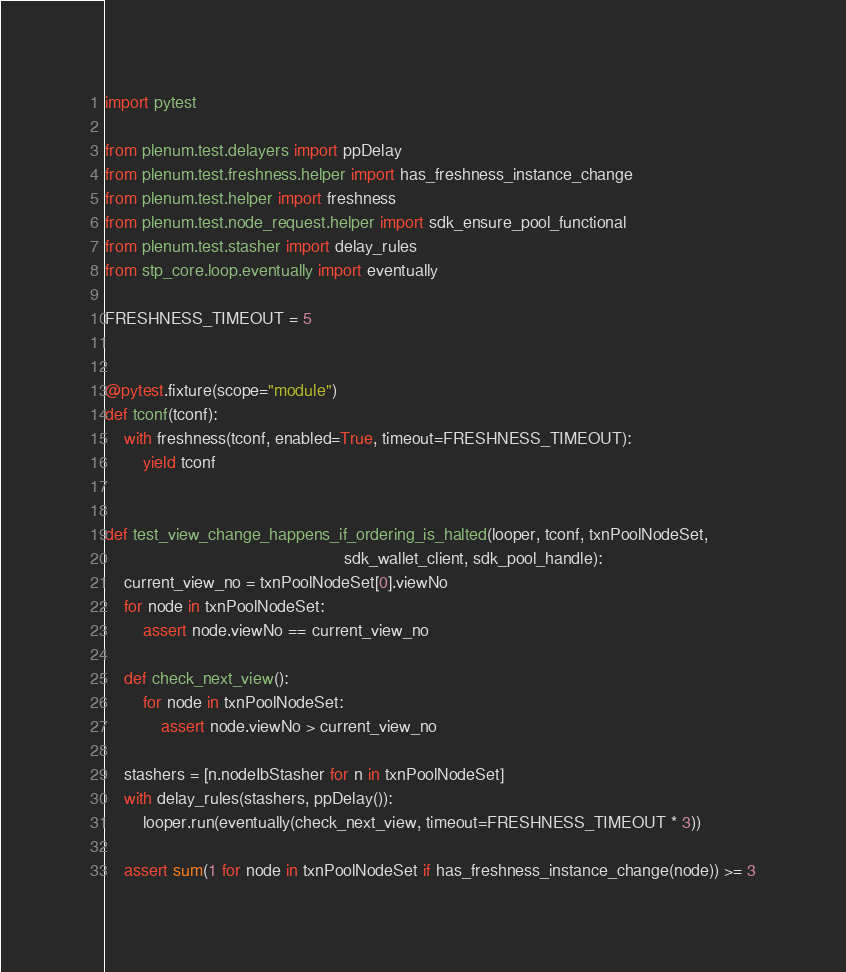Convert code to text. <code><loc_0><loc_0><loc_500><loc_500><_Python_>import pytest

from plenum.test.delayers import ppDelay
from plenum.test.freshness.helper import has_freshness_instance_change
from plenum.test.helper import freshness
from plenum.test.node_request.helper import sdk_ensure_pool_functional
from plenum.test.stasher import delay_rules
from stp_core.loop.eventually import eventually

FRESHNESS_TIMEOUT = 5


@pytest.fixture(scope="module")
def tconf(tconf):
    with freshness(tconf, enabled=True, timeout=FRESHNESS_TIMEOUT):
        yield tconf


def test_view_change_happens_if_ordering_is_halted(looper, tconf, txnPoolNodeSet,
                                                   sdk_wallet_client, sdk_pool_handle):
    current_view_no = txnPoolNodeSet[0].viewNo
    for node in txnPoolNodeSet:
        assert node.viewNo == current_view_no

    def check_next_view():
        for node in txnPoolNodeSet:
            assert node.viewNo > current_view_no

    stashers = [n.nodeIbStasher for n in txnPoolNodeSet]
    with delay_rules(stashers, ppDelay()):
        looper.run(eventually(check_next_view, timeout=FRESHNESS_TIMEOUT * 3))

    assert sum(1 for node in txnPoolNodeSet if has_freshness_instance_change(node)) >= 3
</code> 